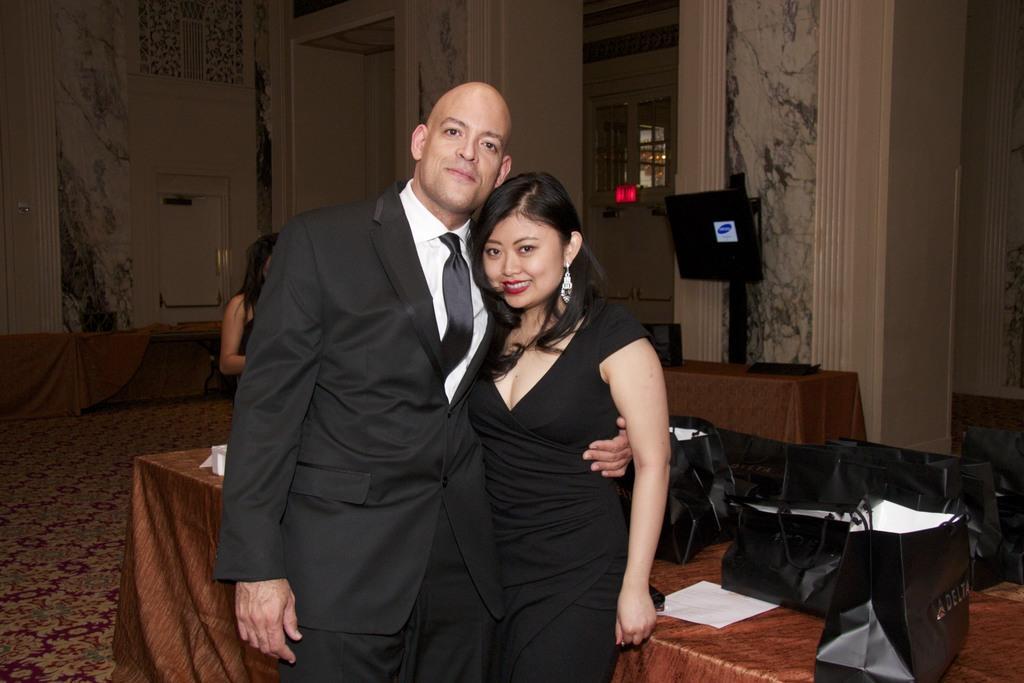In one or two sentences, can you explain what this image depicts? Couple are standing ,on the table we have covers,paper and in the back we have screens,door and wall. 